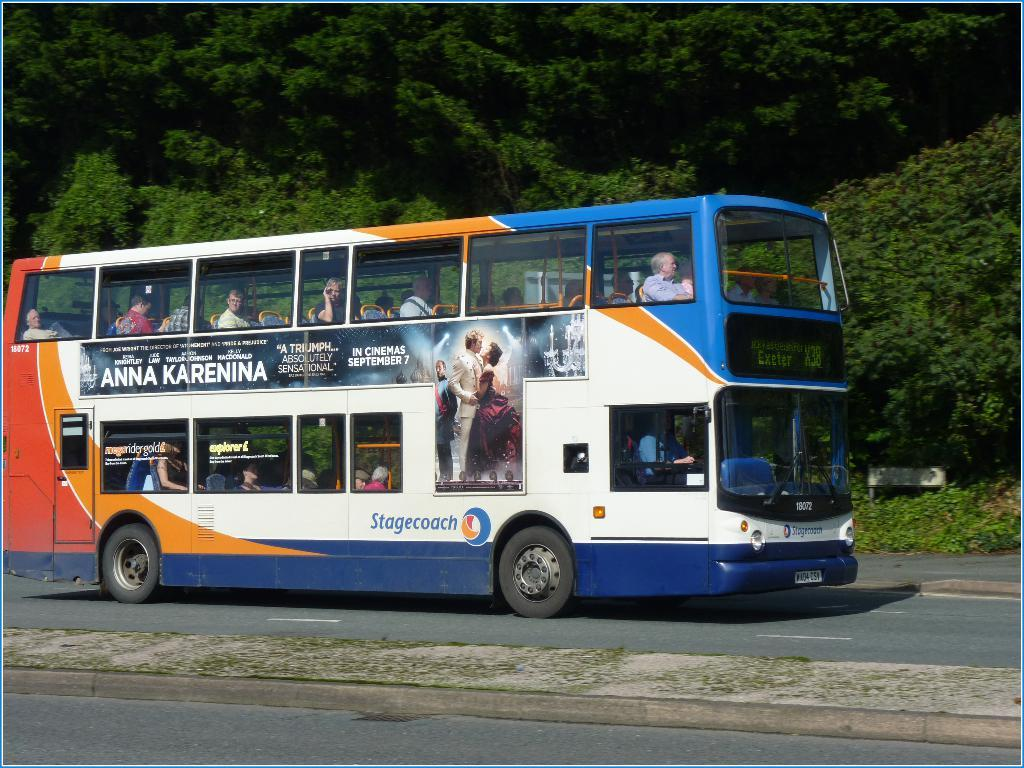What is the main subject of the image? The main subject of the image is a bus. Where is the bus located in the image? The bus is on the road in the image. Can you describe the passengers in the bus? There are people sitting in the bus. What is visible on the bus itself? There is text and a picture on the bus. What can be seen in the background of the image? There are trees in the background of the image. What type of star is visible on the flesh of the passengers in the image? There is no star or flesh visible in the image; it features a bus on the road with people sitting inside. 